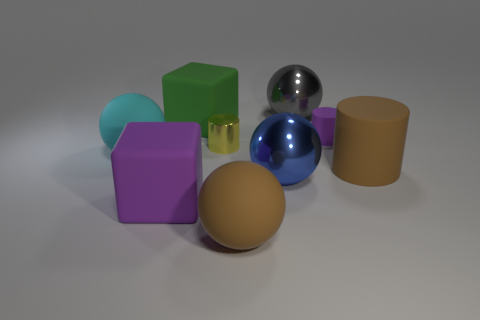Are there any rubber cylinders of the same size as the cyan thing?
Offer a terse response. Yes. Do the tiny matte cylinder and the cube in front of the small yellow metal thing have the same color?
Offer a very short reply. Yes. What is the green block made of?
Give a very brief answer. Rubber. What color is the big sphere that is to the left of the brown rubber sphere?
Keep it short and to the point. Cyan. What number of matte blocks have the same color as the small rubber cylinder?
Keep it short and to the point. 1. What number of big objects are both left of the purple matte cylinder and in front of the big cyan ball?
Ensure brevity in your answer.  3. The blue thing that is the same size as the brown sphere is what shape?
Your response must be concise. Sphere. What size is the yellow metallic cylinder?
Make the answer very short. Small. What is the yellow thing that is behind the brown object in front of the brown cylinder in front of the yellow shiny object made of?
Provide a short and direct response. Metal. The other cylinder that is made of the same material as the big cylinder is what color?
Offer a very short reply. Purple. 